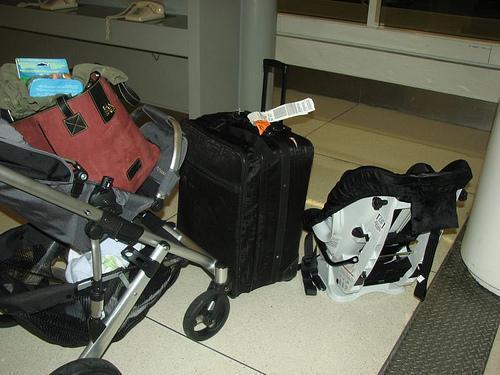How many blue things can be seen?
Give a very brief answer. 2. 